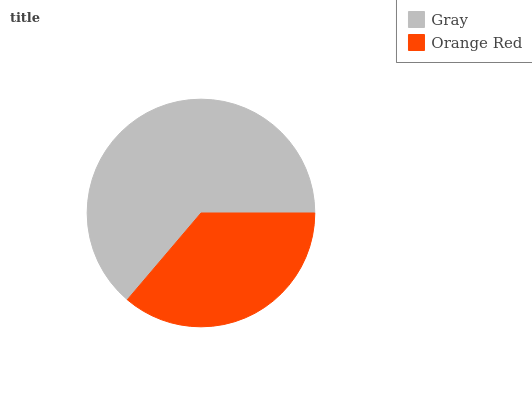Is Orange Red the minimum?
Answer yes or no. Yes. Is Gray the maximum?
Answer yes or no. Yes. Is Orange Red the maximum?
Answer yes or no. No. Is Gray greater than Orange Red?
Answer yes or no. Yes. Is Orange Red less than Gray?
Answer yes or no. Yes. Is Orange Red greater than Gray?
Answer yes or no. No. Is Gray less than Orange Red?
Answer yes or no. No. Is Gray the high median?
Answer yes or no. Yes. Is Orange Red the low median?
Answer yes or no. Yes. Is Orange Red the high median?
Answer yes or no. No. Is Gray the low median?
Answer yes or no. No. 